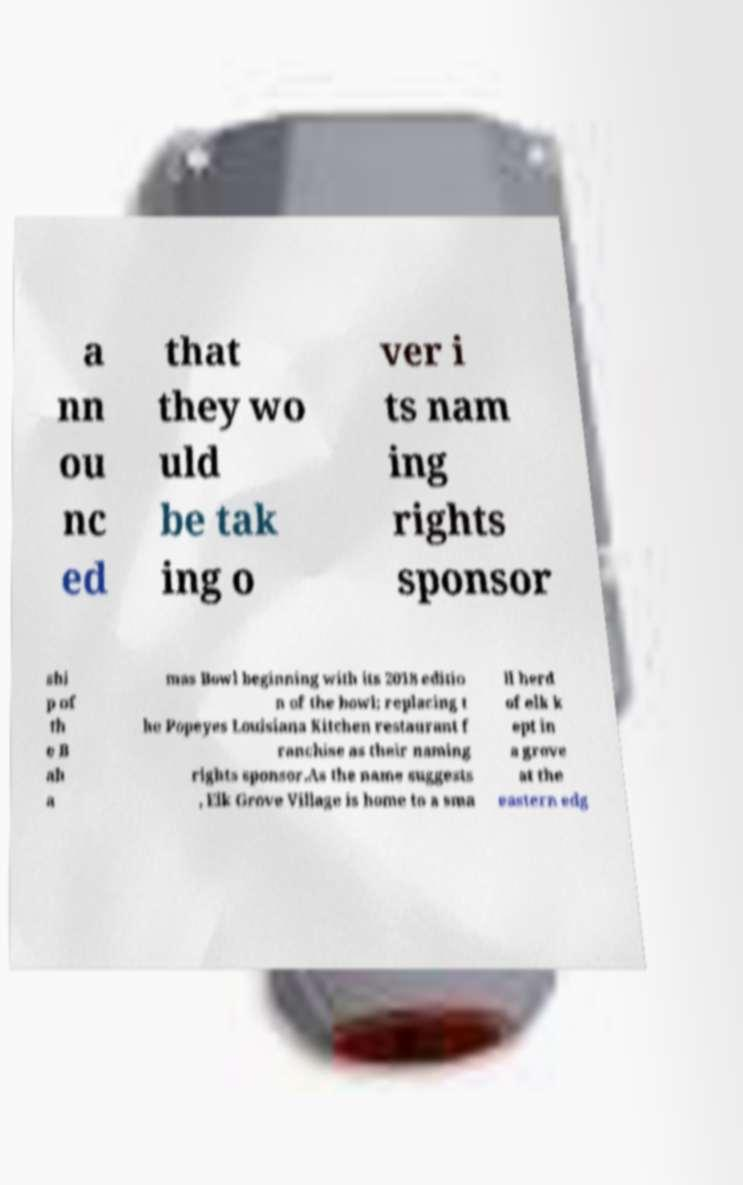There's text embedded in this image that I need extracted. Can you transcribe it verbatim? a nn ou nc ed that they wo uld be tak ing o ver i ts nam ing rights sponsor shi p of th e B ah a mas Bowl beginning with its 2018 editio n of the bowl; replacing t he Popeyes Louisiana Kitchen restaurant f ranchise as their naming rights sponsor.As the name suggests , Elk Grove Village is home to a sma ll herd of elk k ept in a grove at the eastern edg 